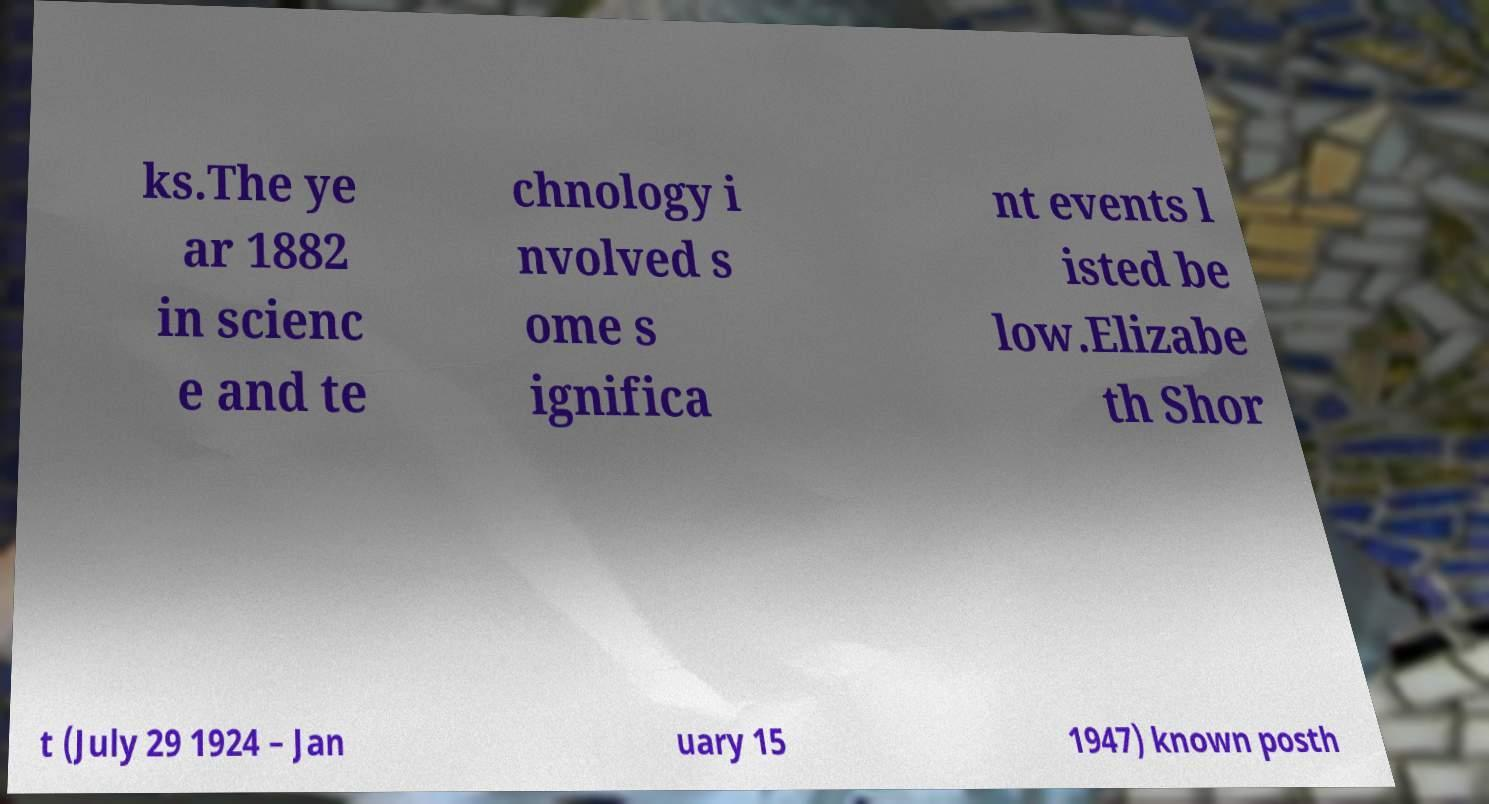What messages or text are displayed in this image? I need them in a readable, typed format. ks.The ye ar 1882 in scienc e and te chnology i nvolved s ome s ignifica nt events l isted be low.Elizabe th Shor t (July 29 1924 – Jan uary 15 1947) known posth 